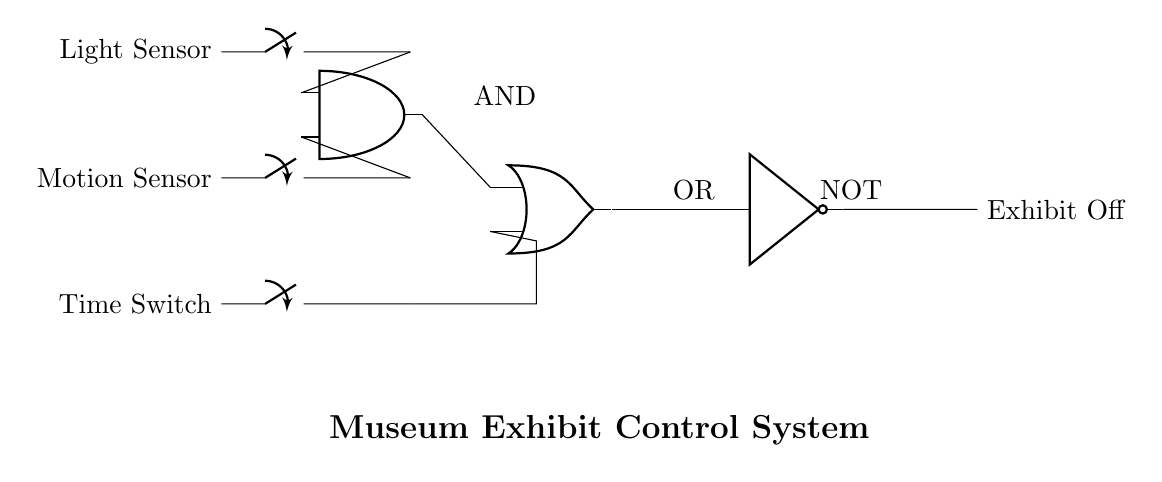What components are involved in this circuit? The circuit includes a light sensor, motion sensor, time switch, an AND gate, an OR gate, and a NOT gate. These elements are visually represented in the circuit diagram.
Answer: light sensor, motion sensor, time switch, AND gate, OR gate, NOT gate How many inputs does the AND gate have? The AND gate in the circuit receives two inputs; one from the light sensor and the other from the motion sensor, as indicated by its two input terminals.
Answer: two What is the output of the OR gate? The output of the OR gate is derived from two inputs: the output from the AND gate and the time switch. The diagram shows a connection from both these components to the OR gate.
Answer: OR gate output What happens if the light sensor is activated but the motion sensor is not? If only the light sensor is activated, the AND gate will not output a signal, since both inputs to the AND gate must be high for it to output. Thus, the output to the OR gate will be low, and the final output from the NOT gate will indicate "Exhibit Off."
Answer: Exhibit Off Which component controls whether the exhibit is off or on? The final output of the circuit is controlled by the NOT gate which takes the output from the OR gate. If the OR gate receives a signal, the NOT gate will output the opposite, turning the exhibit off.
Answer: NOT gate What is the purpose of the NOT gate in this circuit? The NOT gate serves to reverse the output signal it receives from the OR gate, effectively ensuring that a high signal results in a low output, indicating that the exhibit should be turned off when conditions are met.
Answer: reverse output 